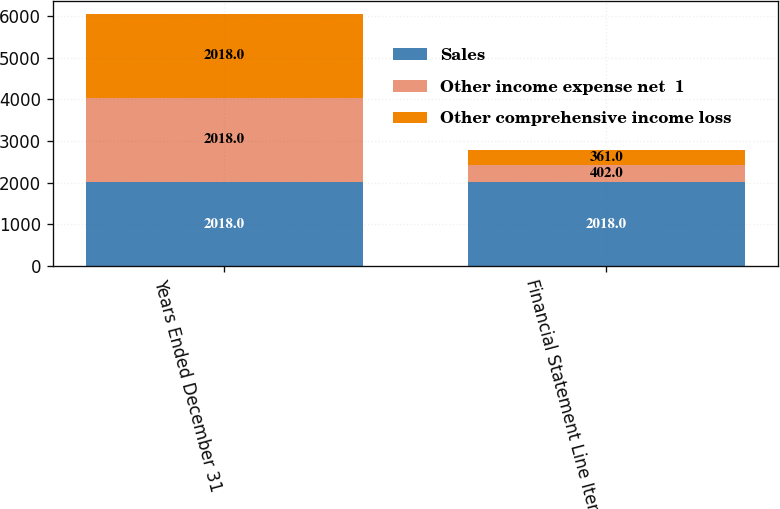Convert chart. <chart><loc_0><loc_0><loc_500><loc_500><stacked_bar_chart><ecel><fcel>Years Ended December 31<fcel>Financial Statement Line Items<nl><fcel>Sales<fcel>2018<fcel>2018<nl><fcel>Other income expense net  1<fcel>2018<fcel>402<nl><fcel>Other comprehensive income loss<fcel>2018<fcel>361<nl></chart> 